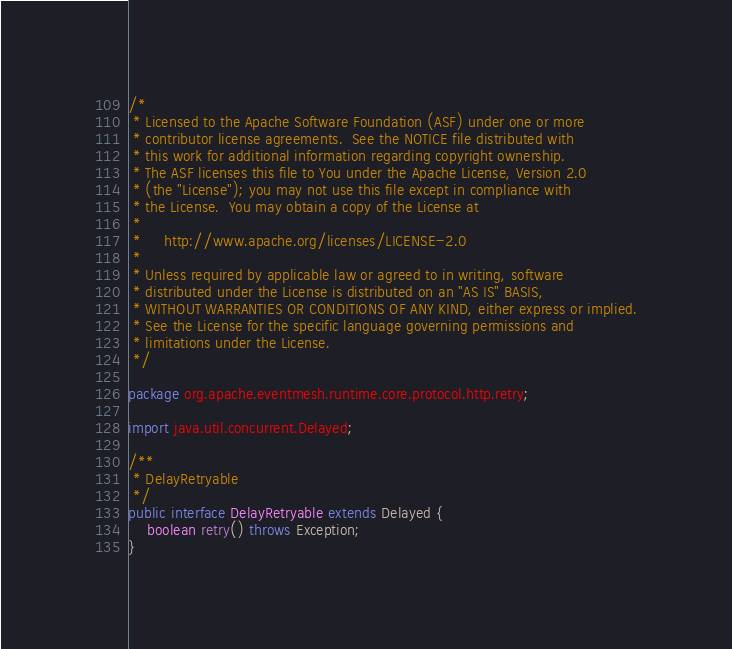<code> <loc_0><loc_0><loc_500><loc_500><_Java_>/*
 * Licensed to the Apache Software Foundation (ASF) under one or more
 * contributor license agreements.  See the NOTICE file distributed with
 * this work for additional information regarding copyright ownership.
 * The ASF licenses this file to You under the Apache License, Version 2.0
 * (the "License"); you may not use this file except in compliance with
 * the License.  You may obtain a copy of the License at
 *
 *     http://www.apache.org/licenses/LICENSE-2.0
 *
 * Unless required by applicable law or agreed to in writing, software
 * distributed under the License is distributed on an "AS IS" BASIS,
 * WITHOUT WARRANTIES OR CONDITIONS OF ANY KIND, either express or implied.
 * See the License for the specific language governing permissions and
 * limitations under the License.
 */

package org.apache.eventmesh.runtime.core.protocol.http.retry;

import java.util.concurrent.Delayed;

/**
 * DelayRetryable
 */
public interface DelayRetryable extends Delayed {
    boolean retry() throws Exception;
}
</code> 